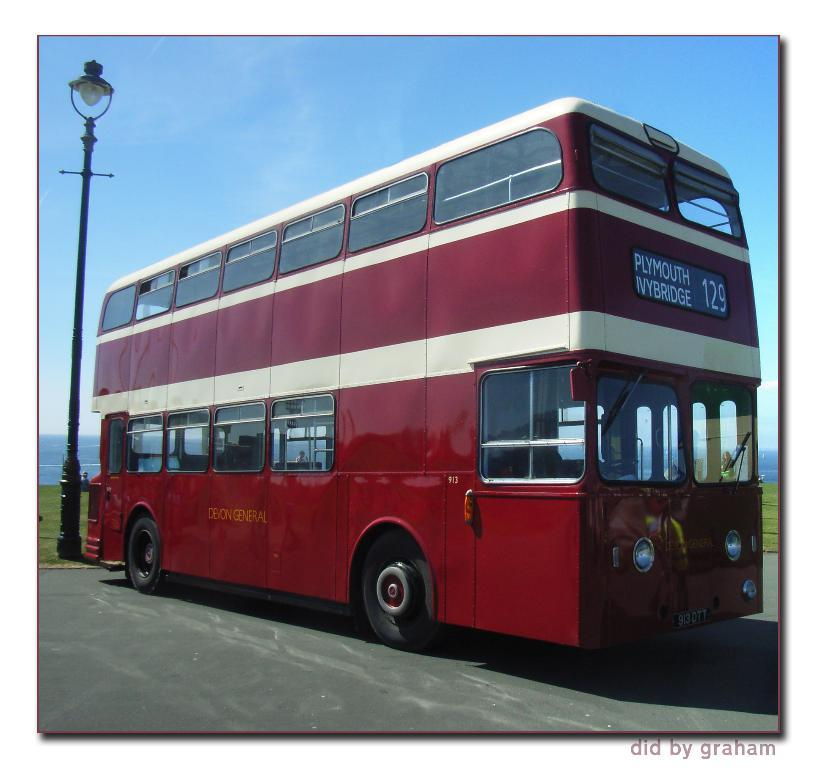What type of vehicle is in the image? There is a red bus in the image. What can be seen on the left side of the image? There is a light pole on the left side of the image. What color is the sky in the image? The sky is visible in the image and has a blue color. How many rabbits can be seen hopping around the red bus in the image? There are no rabbits present in the image; it only features a red bus and a light pole. 